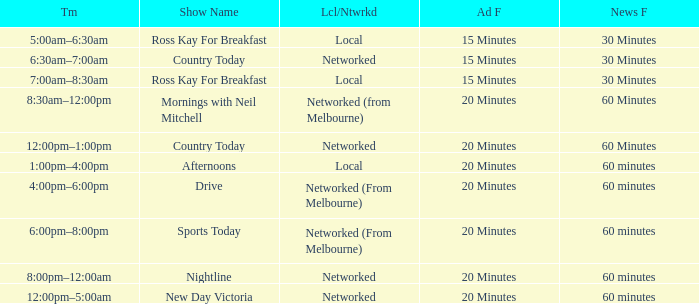What Time has Ad Freq of 15 minutes, and a Show Name of country today? 6:30am–7:00am. 